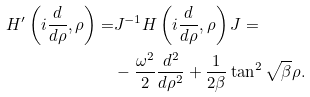Convert formula to latex. <formula><loc_0><loc_0><loc_500><loc_500>H ^ { \prime } \left ( i \frac { d } { d \rho } , \rho \right ) = & J ^ { - 1 } H \left ( i \frac { d } { d \rho } , \rho \right ) J = \\ & - \frac { \omega ^ { 2 } } { 2 } \frac { d ^ { 2 } } { d \rho ^ { 2 } } + \frac { 1 } { 2 \beta } \tan ^ { 2 } \sqrt { \beta } \rho . \\</formula> 